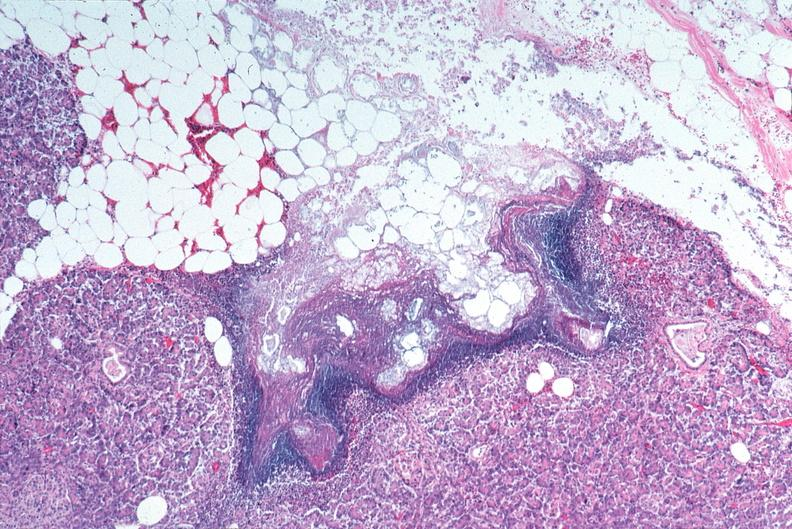what does this image show?
Answer the question using a single word or phrase. Pancreatic fat necrosis 